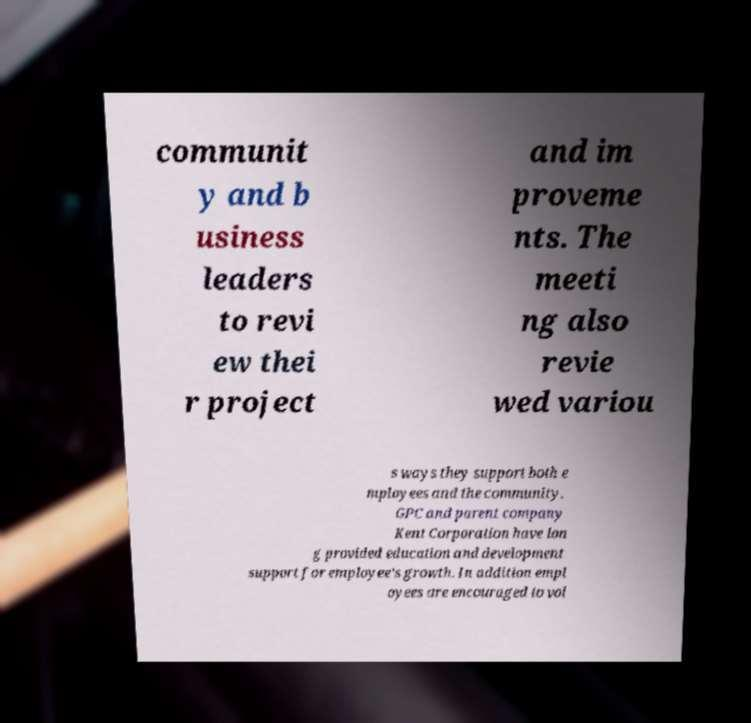What messages or text are displayed in this image? I need them in a readable, typed format. communit y and b usiness leaders to revi ew thei r project and im proveme nts. The meeti ng also revie wed variou s ways they support both e mployees and the community. GPC and parent company Kent Corporation have lon g provided education and development support for employee's growth. In addition empl oyees are encouraged to vol 